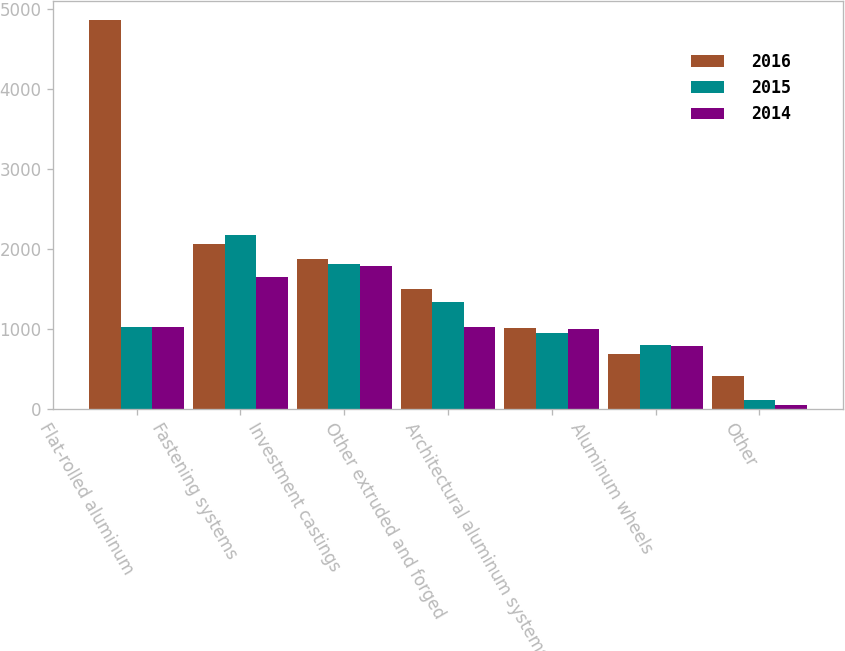<chart> <loc_0><loc_0><loc_500><loc_500><stacked_bar_chart><ecel><fcel>Flat-rolled aluminum<fcel>Fastening systems<fcel>Investment castings<fcel>Other extruded and forged<fcel>Architectural aluminum systems<fcel>Aluminum wheels<fcel>Other<nl><fcel>2016<fcel>4864<fcel>2060<fcel>1870<fcel>1495<fcel>1010<fcel>689<fcel>406<nl><fcel>2015<fcel>1019<fcel>2168<fcel>1812<fcel>1332<fcel>951<fcel>790<fcel>107<nl><fcel>2014<fcel>1019<fcel>1647<fcel>1784<fcel>1019<fcel>1002<fcel>786<fcel>40<nl></chart> 